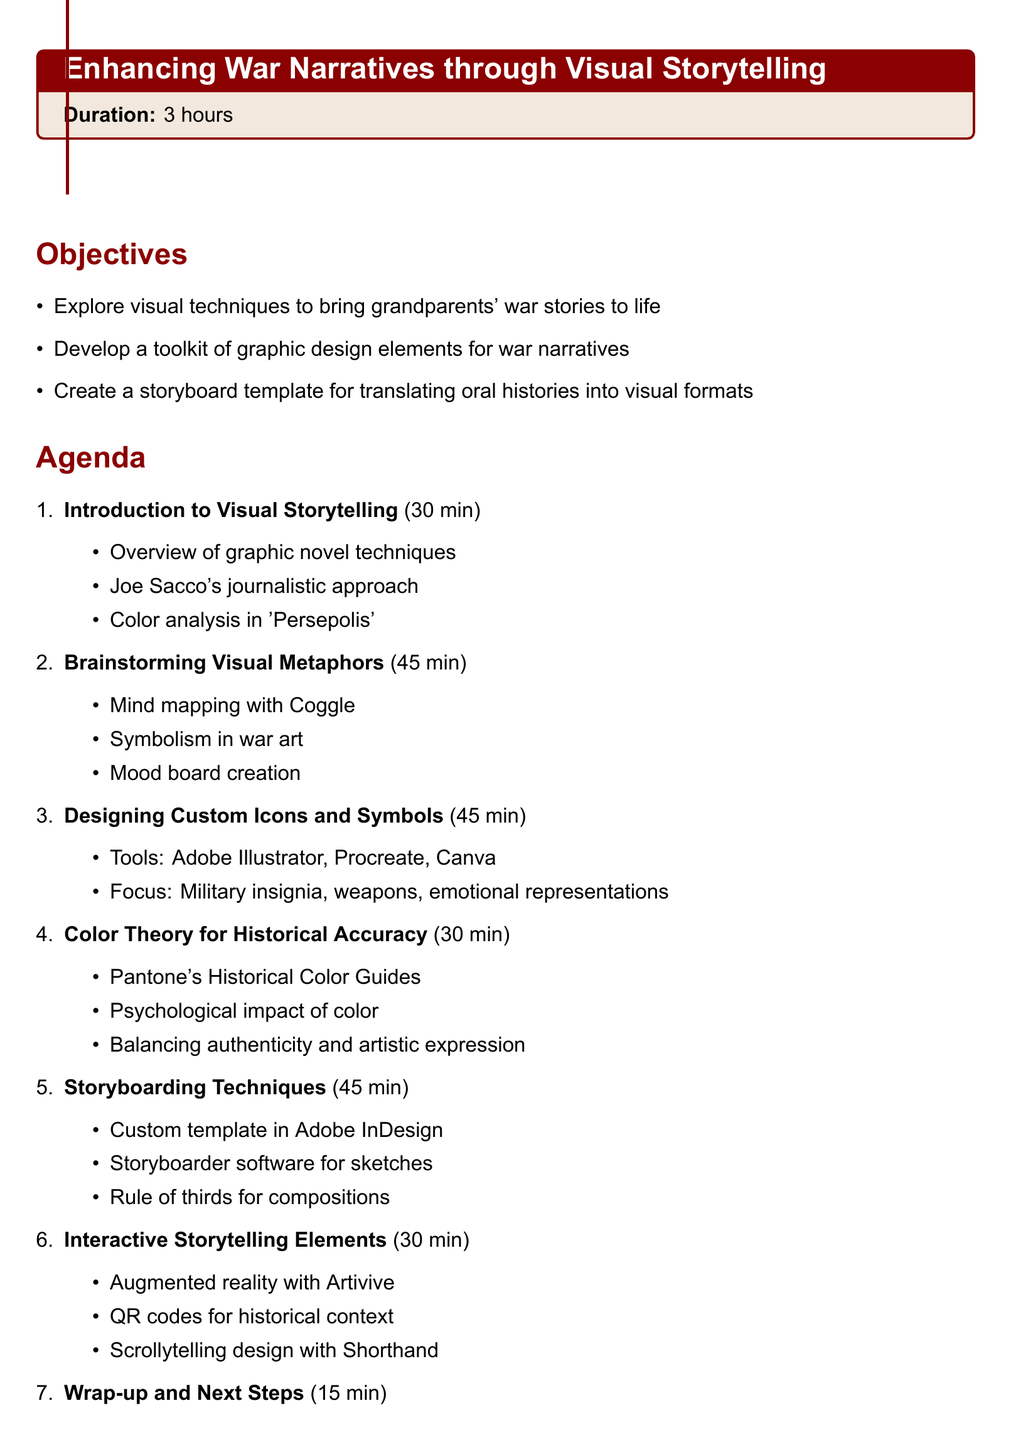What is the duration of the session? The duration is explicitly stated in the document as 3 hours.
Answer: 3 hours What are the key resources mentioned? The document lists a book, software, a website, and a documentary as key resources.
Answer: Book, Software, Website, Documentary Which section covers designing custom icons and symbols? The title of the section specifically addressing this topic is mentioned in the agenda.
Answer: Designing Custom Icons and Symbols What is one of the objectives of the session? The objectives are listed in bullet points, and one can easily extract one from there.
Answer: Explore visual techniques to bring grandparents' war stories to life How long is allocated for color theory discussion? The duration for the discussion on color theory is mentioned in the agenda items section.
Answer: 30 minutes Which software is suggested for creating storyboards? The agenda includes Adobe InDesign as a method for storyboarding techniques.
Answer: Adobe InDesign What type of activity is used for brainstorming visual metaphors? The activities section under the brainstorming item specifically lists a technique utilized.
Answer: Mind mapping exercise How many minutes are allotted to the wrap-up and next steps? The duration is clearly outlined in the final agenda item.
Answer: 15 minutes 